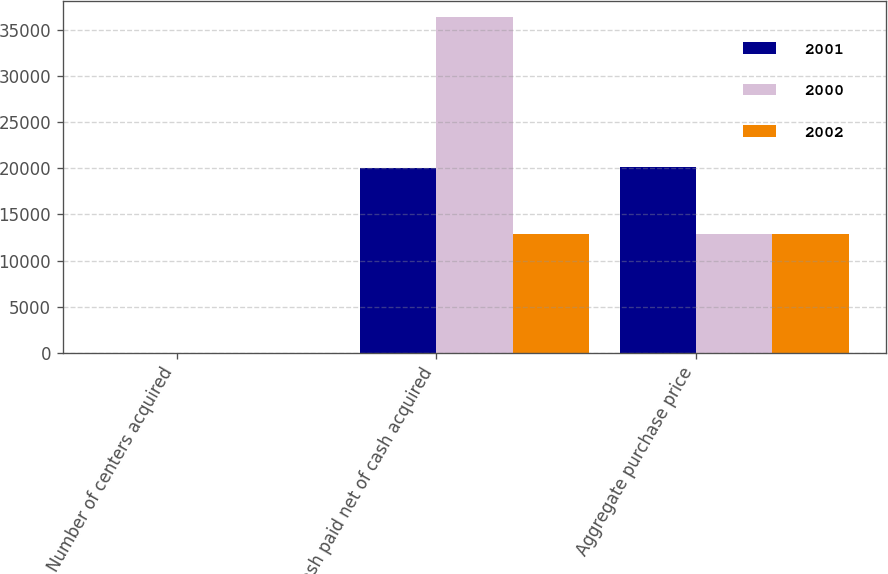Convert chart. <chart><loc_0><loc_0><loc_500><loc_500><stacked_bar_chart><ecel><fcel>Number of centers acquired<fcel>Cash paid net of cash acquired<fcel>Aggregate purchase price<nl><fcel>2001<fcel>11<fcel>19977<fcel>20077<nl><fcel>2000<fcel>21<fcel>36330<fcel>12895<nl><fcel>2002<fcel>8<fcel>12895<fcel>12895<nl></chart> 